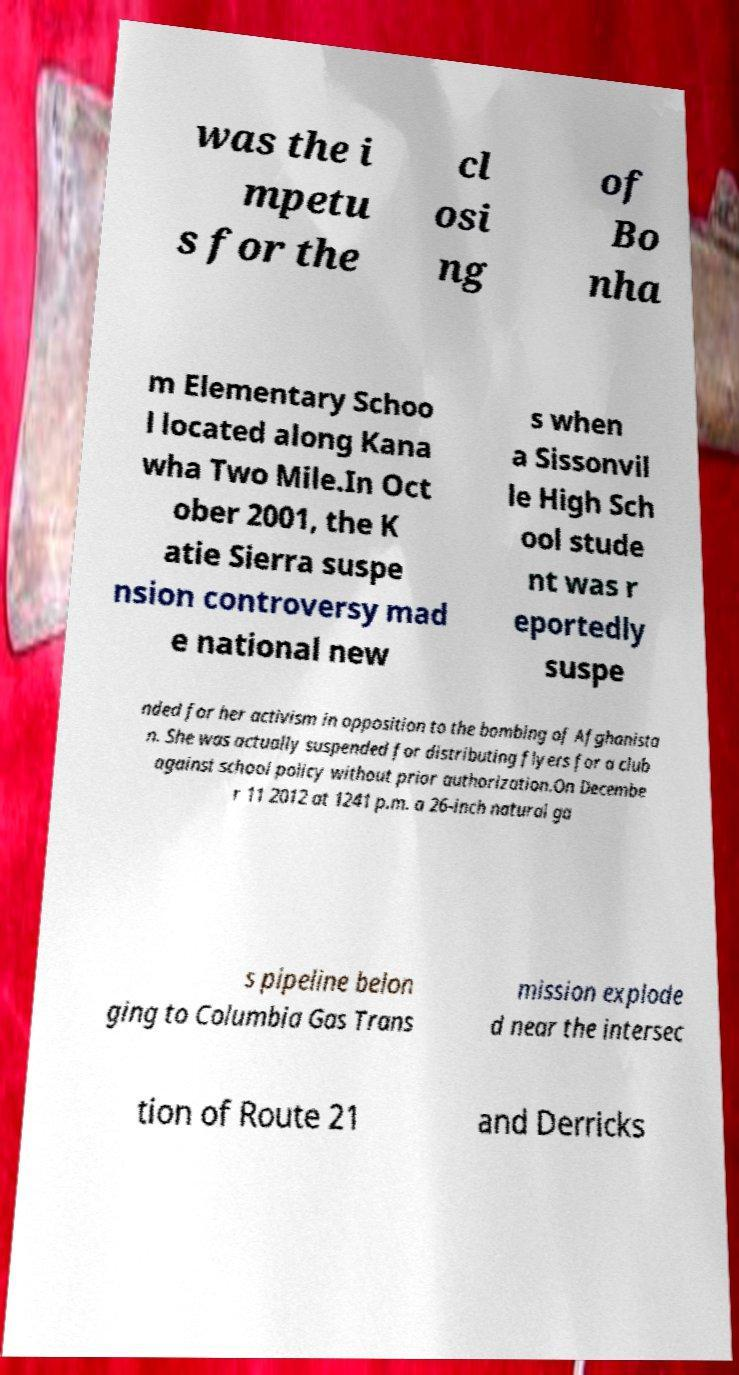Could you assist in decoding the text presented in this image and type it out clearly? was the i mpetu s for the cl osi ng of Bo nha m Elementary Schoo l located along Kana wha Two Mile.In Oct ober 2001, the K atie Sierra suspe nsion controversy mad e national new s when a Sissonvil le High Sch ool stude nt was r eportedly suspe nded for her activism in opposition to the bombing of Afghanista n. She was actually suspended for distributing flyers for a club against school policy without prior authorization.On Decembe r 11 2012 at 1241 p.m. a 26-inch natural ga s pipeline belon ging to Columbia Gas Trans mission explode d near the intersec tion of Route 21 and Derricks 